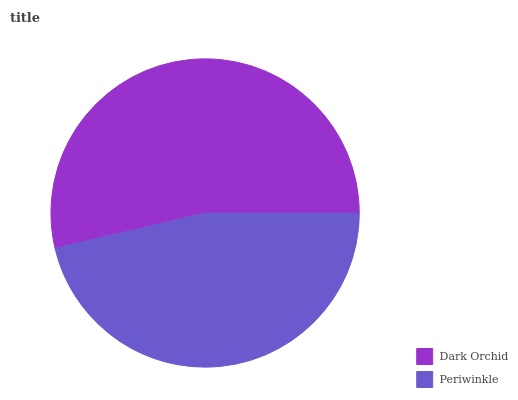Is Periwinkle the minimum?
Answer yes or no. Yes. Is Dark Orchid the maximum?
Answer yes or no. Yes. Is Periwinkle the maximum?
Answer yes or no. No. Is Dark Orchid greater than Periwinkle?
Answer yes or no. Yes. Is Periwinkle less than Dark Orchid?
Answer yes or no. Yes. Is Periwinkle greater than Dark Orchid?
Answer yes or no. No. Is Dark Orchid less than Periwinkle?
Answer yes or no. No. Is Dark Orchid the high median?
Answer yes or no. Yes. Is Periwinkle the low median?
Answer yes or no. Yes. Is Periwinkle the high median?
Answer yes or no. No. Is Dark Orchid the low median?
Answer yes or no. No. 